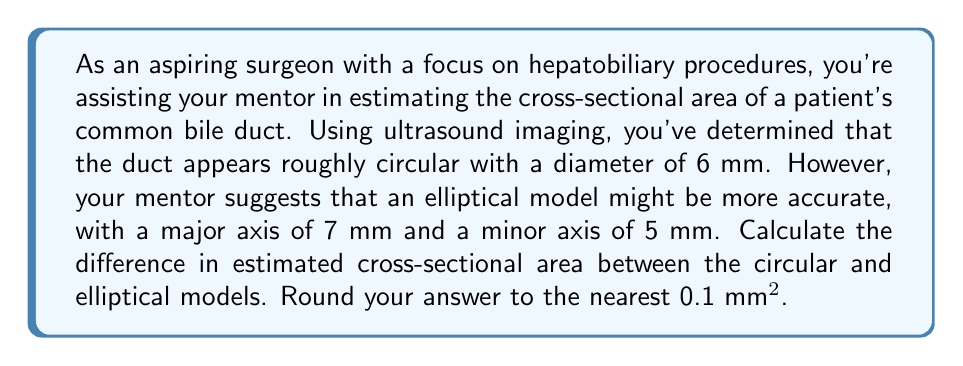Can you answer this question? To solve this problem, we need to calculate the area of both the circular and elliptical models, then find the difference between them.

1. Circular model:
   The area of a circle is given by the formula $A = \pi r^2$, where $r$ is the radius.
   Diameter = 6 mm, so radius = 3 mm
   $$A_{circle} = \pi (3\text{ mm})^2 = 9\pi \text{ mm}^2 \approx 28.27 \text{ mm}^2$$

2. Elliptical model:
   The area of an ellipse is given by the formula $A = \pi ab$, where $a$ and $b$ are the semi-major and semi-minor axes, respectively.
   Major axis = 7 mm, so $a = 3.5$ mm
   Minor axis = 5 mm, so $b = 2.5$ mm
   $$A_{ellipse} = \pi (3.5\text{ mm})(2.5\text{ mm}) = 8.75\pi \text{ mm}^2 \approx 27.49 \text{ mm}^2$$

3. Difference in area:
   $$\text{Difference} = A_{circle} - A_{ellipse} = 28.27 \text{ mm}^2 - 27.49 \text{ mm}^2 = 0.78 \text{ mm}^2$$

Rounding to the nearest 0.1 mm², we get 0.8 mm².
Answer: 0.8 mm² 